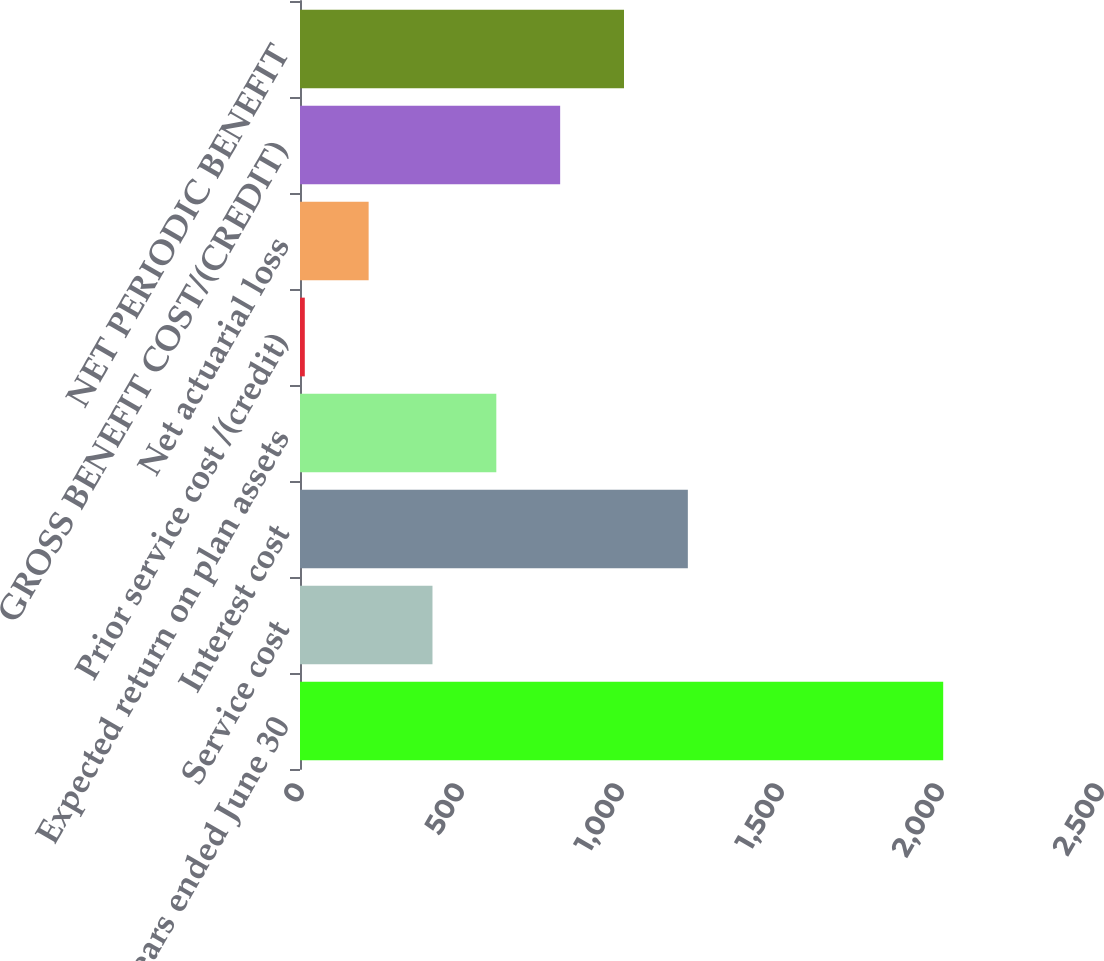Convert chart to OTSL. <chart><loc_0><loc_0><loc_500><loc_500><bar_chart><fcel>Years ended June 30<fcel>Service cost<fcel>Interest cost<fcel>Expected return on plan assets<fcel>Prior service cost /(credit)<fcel>Net actuarial loss<fcel>GROSS BENEFIT COST/(CREDIT)<fcel>NET PERIODIC BENEFIT<nl><fcel>2010<fcel>414<fcel>1212<fcel>613.5<fcel>15<fcel>214.5<fcel>813<fcel>1012.5<nl></chart> 